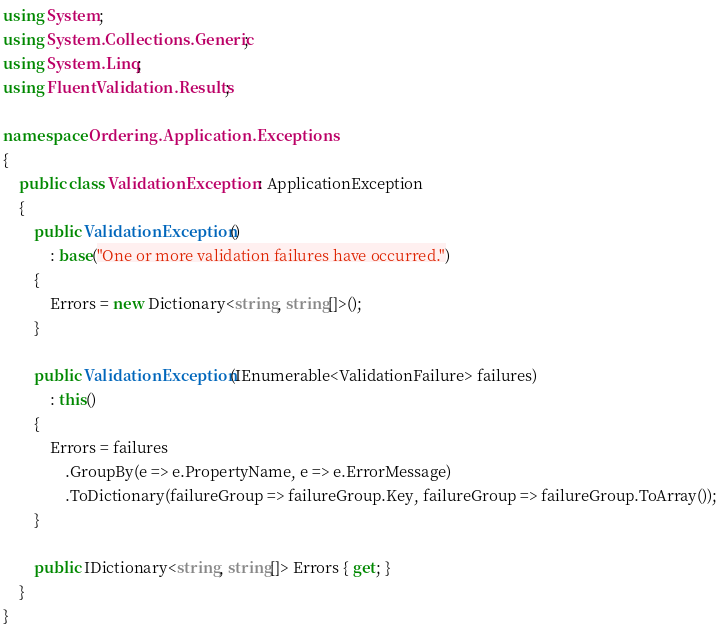Convert code to text. <code><loc_0><loc_0><loc_500><loc_500><_C#_>using System;
using System.Collections.Generic;
using System.Linq;
using FluentValidation.Results;

namespace Ordering.Application.Exceptions
{
    public class ValidationException : ApplicationException
    {
        public ValidationException()
            : base("One or more validation failures have occurred.")
        {
            Errors = new Dictionary<string, string[]>();
        }

        public ValidationException(IEnumerable<ValidationFailure> failures)
            : this()
        {
            Errors = failures
                .GroupBy(e => e.PropertyName, e => e.ErrorMessage)
                .ToDictionary(failureGroup => failureGroup.Key, failureGroup => failureGroup.ToArray());
        }

        public IDictionary<string, string[]> Errors { get; }
    }
}</code> 